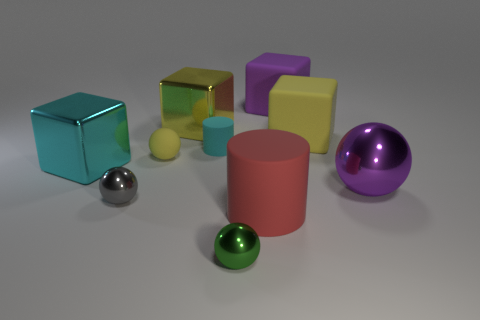What number of big metal objects are on the right side of the cyan metallic object and behind the big sphere?
Provide a succinct answer. 1. What is the size of the red matte thing that is the same shape as the cyan rubber object?
Your answer should be compact. Large. How many purple objects have the same material as the cyan cylinder?
Make the answer very short. 1. Are there fewer big yellow cubes that are in front of the large cyan shiny object than big cyan metallic cylinders?
Provide a succinct answer. No. How many red rubber cylinders are there?
Your answer should be compact. 1. How many big things have the same color as the large cylinder?
Your response must be concise. 0. Does the green thing have the same shape as the tiny cyan thing?
Your answer should be very brief. No. How big is the cyan object that is right of the shiny thing that is to the left of the small gray thing?
Keep it short and to the point. Small. Is there a yellow cube of the same size as the purple shiny thing?
Your answer should be very brief. Yes. Does the yellow matte thing that is to the right of the tiny green ball have the same size as the yellow rubber object on the left side of the cyan cylinder?
Offer a very short reply. No. 